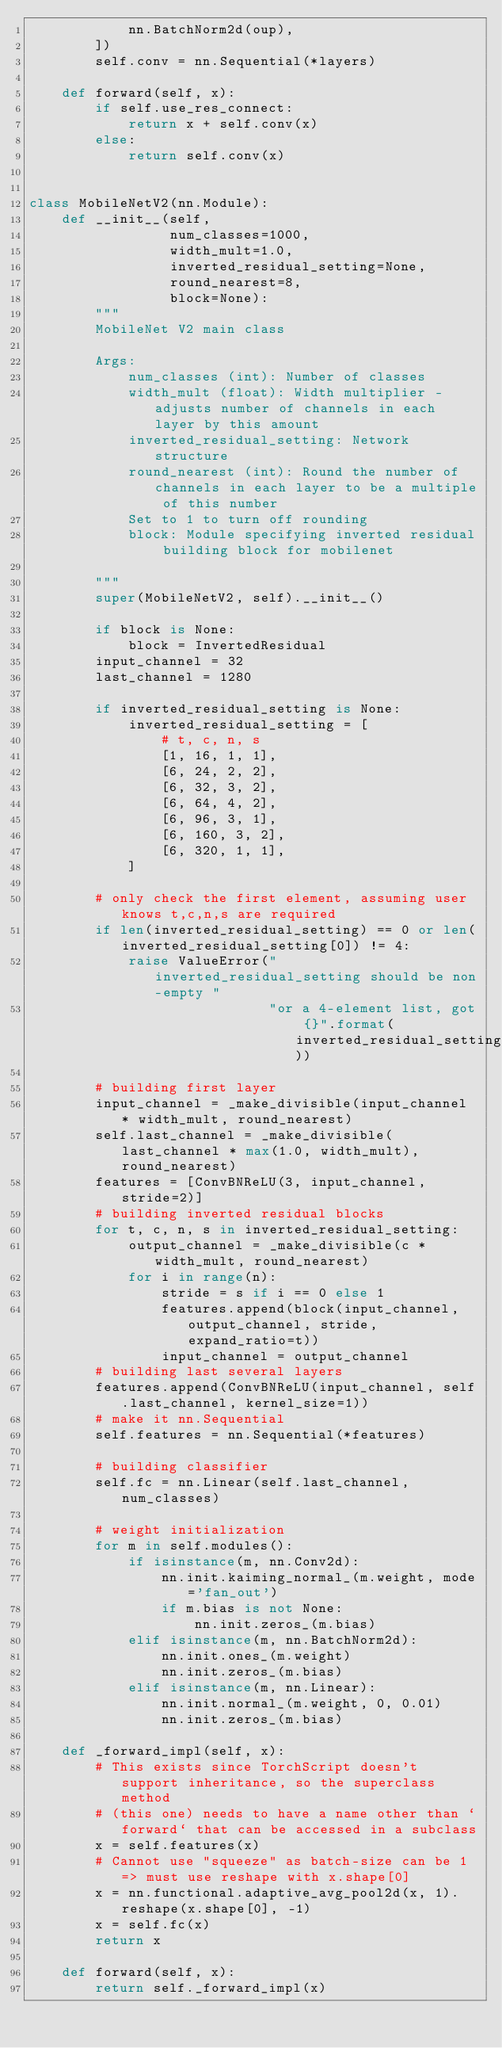<code> <loc_0><loc_0><loc_500><loc_500><_Python_>            nn.BatchNorm2d(oup),
        ])
        self.conv = nn.Sequential(*layers)

    def forward(self, x):
        if self.use_res_connect:
            return x + self.conv(x)
        else:
            return self.conv(x)


class MobileNetV2(nn.Module):
    def __init__(self,
                 num_classes=1000,
                 width_mult=1.0,
                 inverted_residual_setting=None,
                 round_nearest=8,
                 block=None):
        """
        MobileNet V2 main class

        Args:
            num_classes (int): Number of classes
            width_mult (float): Width multiplier - adjusts number of channels in each layer by this amount
            inverted_residual_setting: Network structure
            round_nearest (int): Round the number of channels in each layer to be a multiple of this number
            Set to 1 to turn off rounding
            block: Module specifying inverted residual building block for mobilenet

        """
        super(MobileNetV2, self).__init__()

        if block is None:
            block = InvertedResidual
        input_channel = 32
        last_channel = 1280

        if inverted_residual_setting is None:
            inverted_residual_setting = [
                # t, c, n, s
                [1, 16, 1, 1],
                [6, 24, 2, 2],
                [6, 32, 3, 2],
                [6, 64, 4, 2],
                [6, 96, 3, 1],
                [6, 160, 3, 2],
                [6, 320, 1, 1],
            ]

        # only check the first element, assuming user knows t,c,n,s are required
        if len(inverted_residual_setting) == 0 or len(inverted_residual_setting[0]) != 4:
            raise ValueError("inverted_residual_setting should be non-empty "
                             "or a 4-element list, got {}".format(inverted_residual_setting))

        # building first layer
        input_channel = _make_divisible(input_channel * width_mult, round_nearest)
        self.last_channel = _make_divisible(last_channel * max(1.0, width_mult), round_nearest)
        features = [ConvBNReLU(3, input_channel, stride=2)]
        # building inverted residual blocks
        for t, c, n, s in inverted_residual_setting:
            output_channel = _make_divisible(c * width_mult, round_nearest)
            for i in range(n):
                stride = s if i == 0 else 1
                features.append(block(input_channel, output_channel, stride, expand_ratio=t))
                input_channel = output_channel
        # building last several layers
        features.append(ConvBNReLU(input_channel, self.last_channel, kernel_size=1))
        # make it nn.Sequential
        self.features = nn.Sequential(*features)

        # building classifier
        self.fc = nn.Linear(self.last_channel, num_classes)

        # weight initialization
        for m in self.modules():
            if isinstance(m, nn.Conv2d):
                nn.init.kaiming_normal_(m.weight, mode='fan_out')
                if m.bias is not None:
                    nn.init.zeros_(m.bias)
            elif isinstance(m, nn.BatchNorm2d):
                nn.init.ones_(m.weight)
                nn.init.zeros_(m.bias)
            elif isinstance(m, nn.Linear):
                nn.init.normal_(m.weight, 0, 0.01)
                nn.init.zeros_(m.bias)

    def _forward_impl(self, x):
        # This exists since TorchScript doesn't support inheritance, so the superclass method
        # (this one) needs to have a name other than `forward` that can be accessed in a subclass
        x = self.features(x)
        # Cannot use "squeeze" as batch-size can be 1 => must use reshape with x.shape[0]
        x = nn.functional.adaptive_avg_pool2d(x, 1).reshape(x.shape[0], -1)
        x = self.fc(x)
        return x

    def forward(self, x):
        return self._forward_impl(x)
</code> 